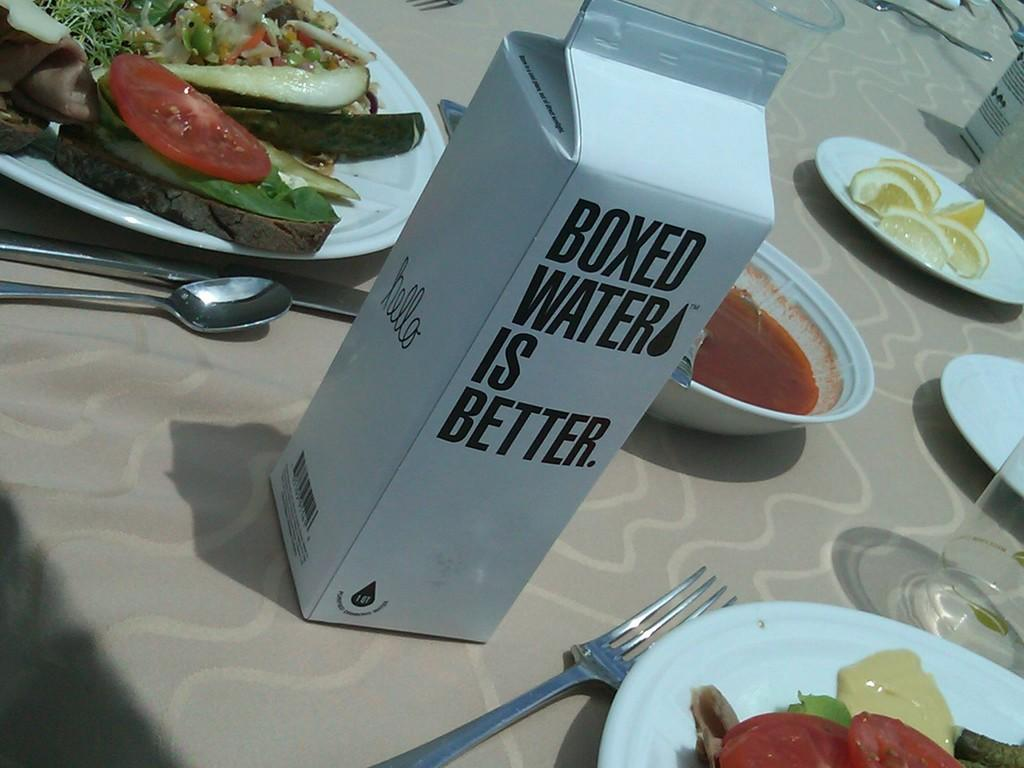What is covering the table in the image? There is a tablecloth in the image. What utensils can be seen in the image? There are forks, spoons, and plates in the image. What type of dish is present in the image? There is a bowl in the image. What is contained in the packet in the image? The contents of the packet are not visible in the image. What type of containers are present in the image? There are glasses in the image. What is the primary purpose of the objects in the image? The objects in the image are used for serving and consuming food. What type of suit is hanging on the shelf in the image? There is no suit or shelf present in the image. How does the death of the person in the image affect the food being served? There is no person or death depicted in the image, so this question cannot be answered. 